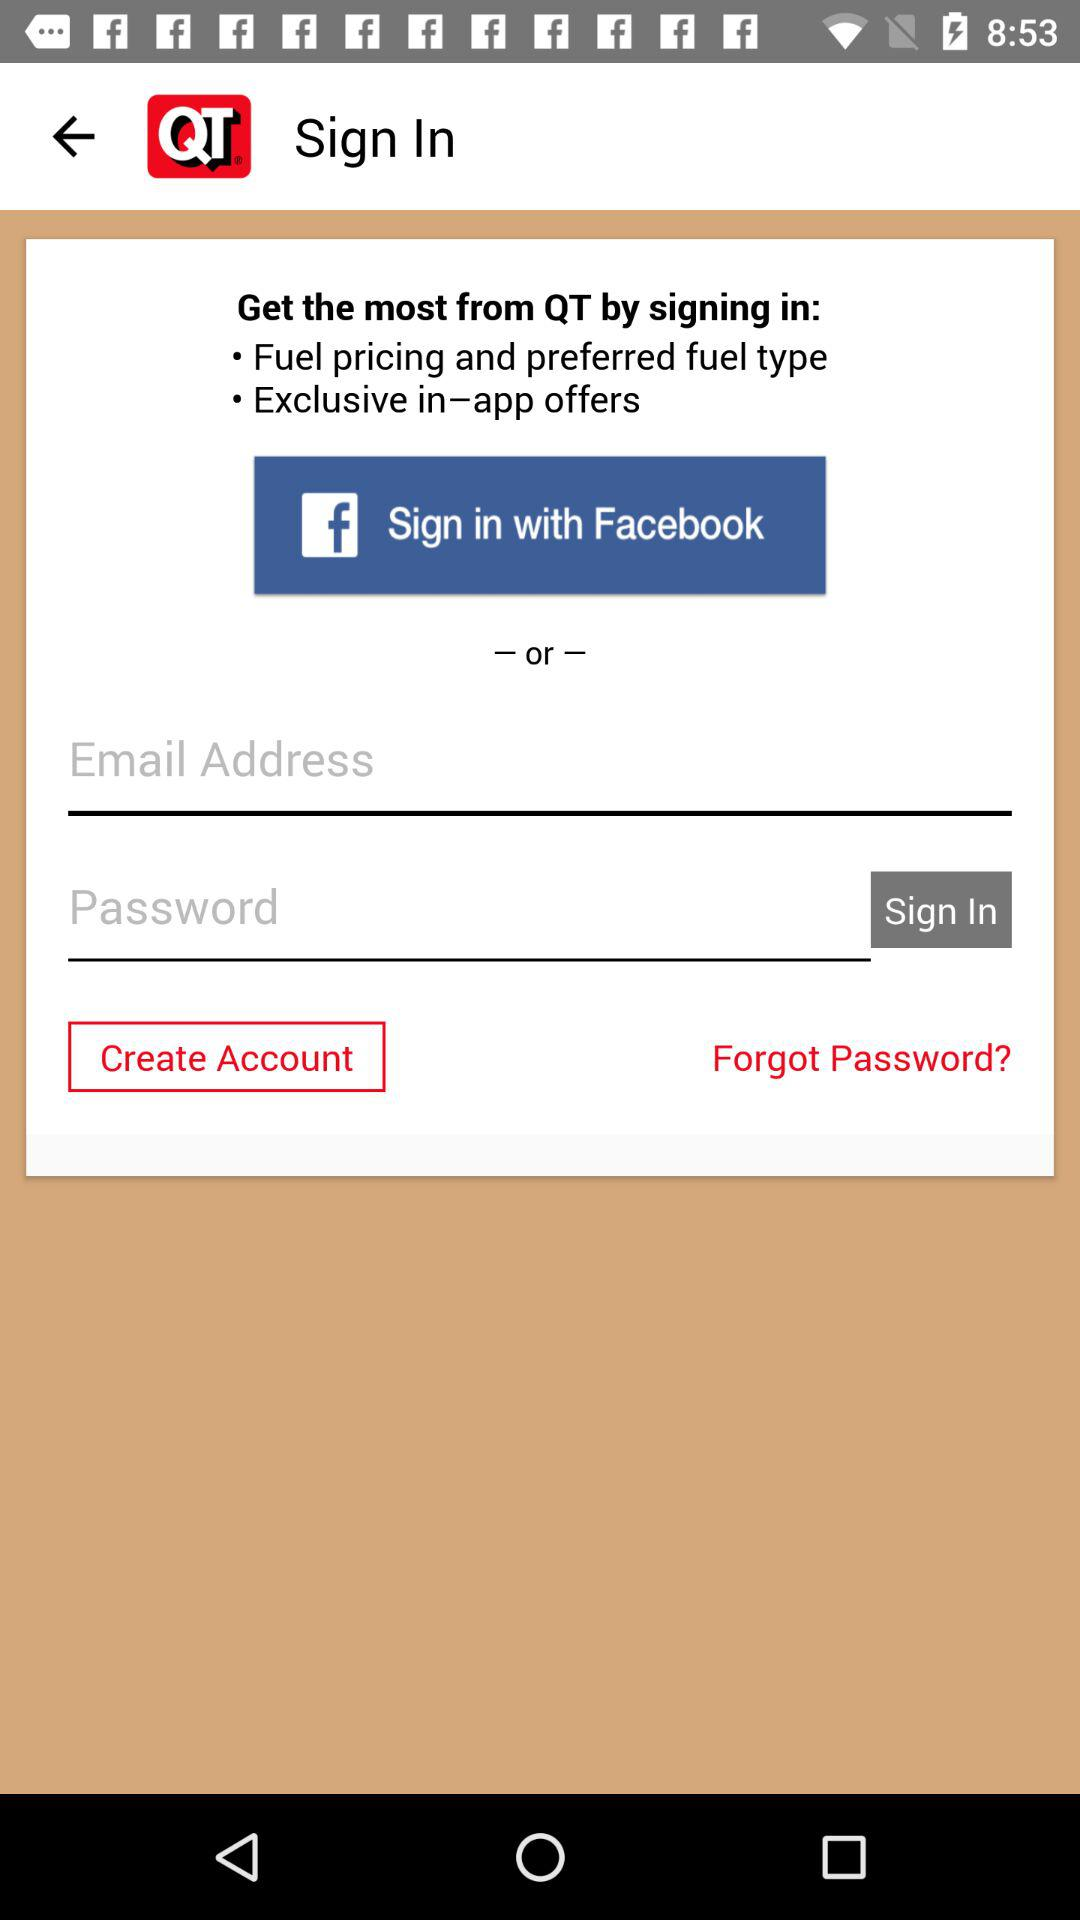With which account can signing in be done? Signing in can be done with "Facebook" and "Email" accounts. 